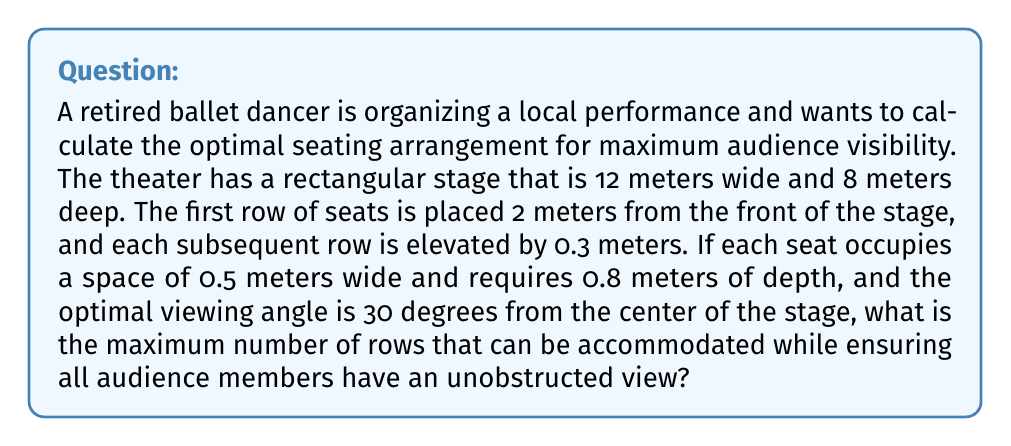Provide a solution to this math problem. To solve this problem, we need to consider the geometry of the theater and the viewing angles. Let's break it down step by step:

1. First, we need to calculate the height of the stage from the audience's perspective. Given that the optimal viewing angle is 30 degrees, we can use trigonometry:

   $$\tan(30°) = \frac{\text{height}}{\text{distance}}$$

   The distance from the first row to the center of the stage is:
   $$2 \text{ m} + \frac{8 \text{ m}}{2} = 6 \text{ m}$$

   Now we can calculate the height:
   $$\text{height} = 6 \text{ m} \cdot \tan(30°) \approx 3.464 \text{ m}$$

2. Each subsequent row is elevated by 0.3 meters. We need to find how many rows can fit within this 3.464 m height:

   $$\text{Number of rows} = \frac{3.464 \text{ m}}{0.3 \text{ m/row}} \approx 11.55$$

3. Since we can't have a fractional number of rows, we round down to 11 rows.

4. Now we need to check if these 11 rows can fit in the depth of the theater. Each row requires 0.8 meters of depth:

   $$\text{Total depth} = 2 \text{ m} + (11 \cdot 0.8 \text{ m}) = 10.8 \text{ m}$$

   This is greater than the 8 meters of stage depth plus 2 meters in front, so we need to reduce the number of rows.

5. Let's calculate the maximum number of rows that can fit in the available depth:

   $$\text{Available depth} = 8 \text{ m} + 2 \text{ m} = 10 \text{ m}$$
   $$\text{Number of rows} = \frac{10 \text{ m} - 2 \text{ m}}{0.8 \text{ m/row}} = 10 \text{ rows}$$

6. Finally, we need to verify that the 10th row doesn't exceed the height we calculated in step 1:

   $$\text{Height of 10th row} = 10 \cdot 0.3 \text{ m} = 3 \text{ m}$$

   This is less than 3.464 m, so it's acceptable.

Therefore, the maximum number of rows that can be accommodated while ensuring all audience members have an unobstructed view is 10 rows.
Answer: 10 rows 